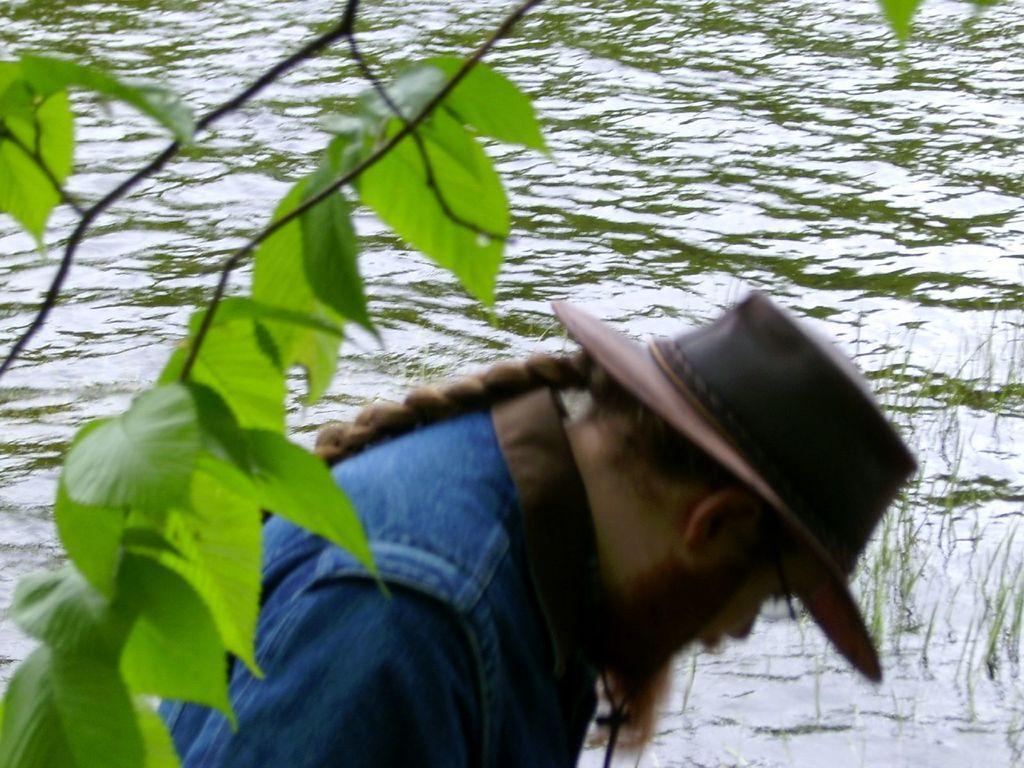Could you give a brief overview of what you see in this image? In this image there is a person standing beside the water, also there is a branch of tree. 